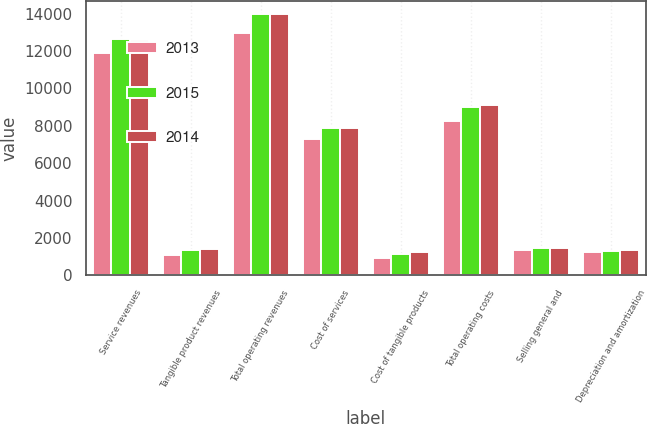<chart> <loc_0><loc_0><loc_500><loc_500><stacked_bar_chart><ecel><fcel>Service revenues<fcel>Tangible product revenues<fcel>Total operating revenues<fcel>Cost of services<fcel>Cost of tangible products<fcel>Total operating costs<fcel>Selling general and<fcel>Depreciation and amortization<nl><fcel>2013<fcel>11887<fcel>1074<fcel>12961<fcel>7281<fcel>950<fcel>8231<fcel>1343<fcel>1245<nl><fcel>2015<fcel>12646<fcel>1350<fcel>13996<fcel>7856<fcel>1146<fcel>9002<fcel>1481<fcel>1292<nl><fcel>2014<fcel>12566<fcel>1417<fcel>13983<fcel>7880<fcel>1232<fcel>9112<fcel>1468<fcel>1333<nl></chart> 